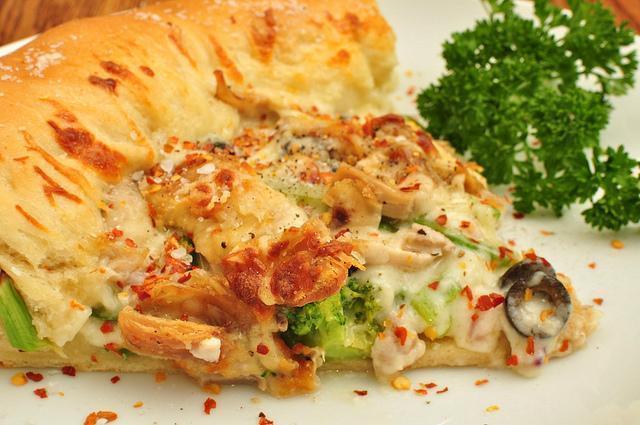How many broccolis are visible?
Give a very brief answer. 2. How many people are waiting for the train?
Give a very brief answer. 0. 